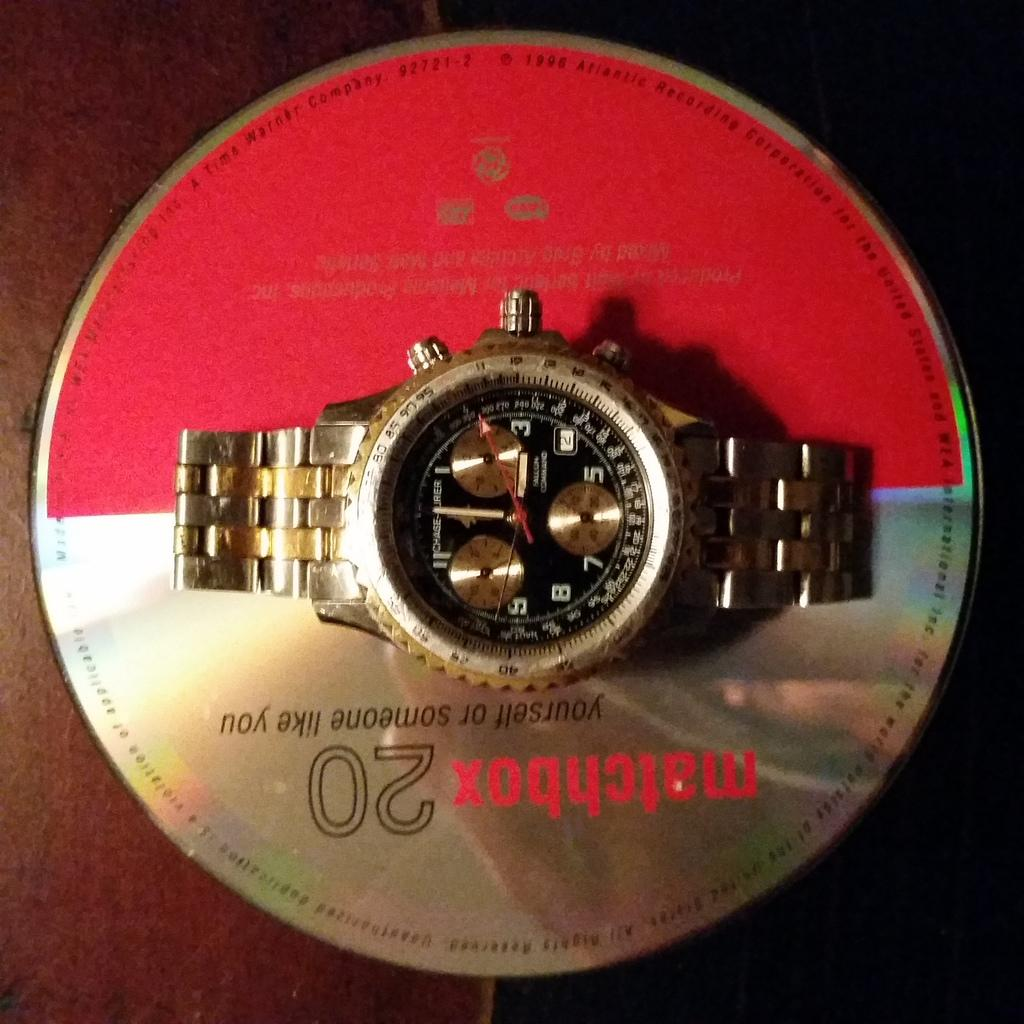<image>
Describe the image concisely. A watch sets upon a Matchbox Twenty CD. 